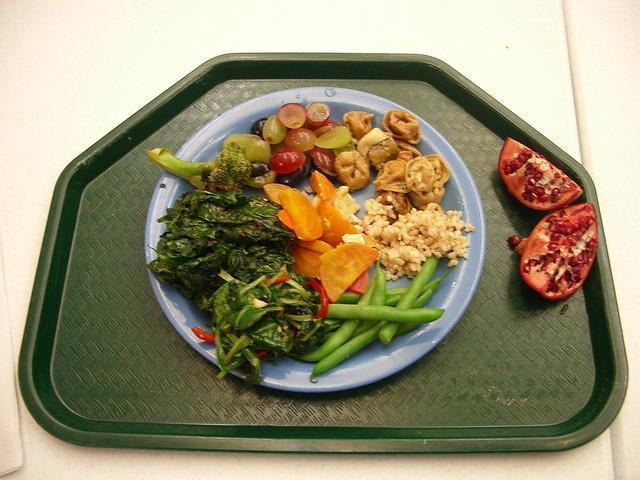How many birds are on the beach?
Give a very brief answer. 0. 